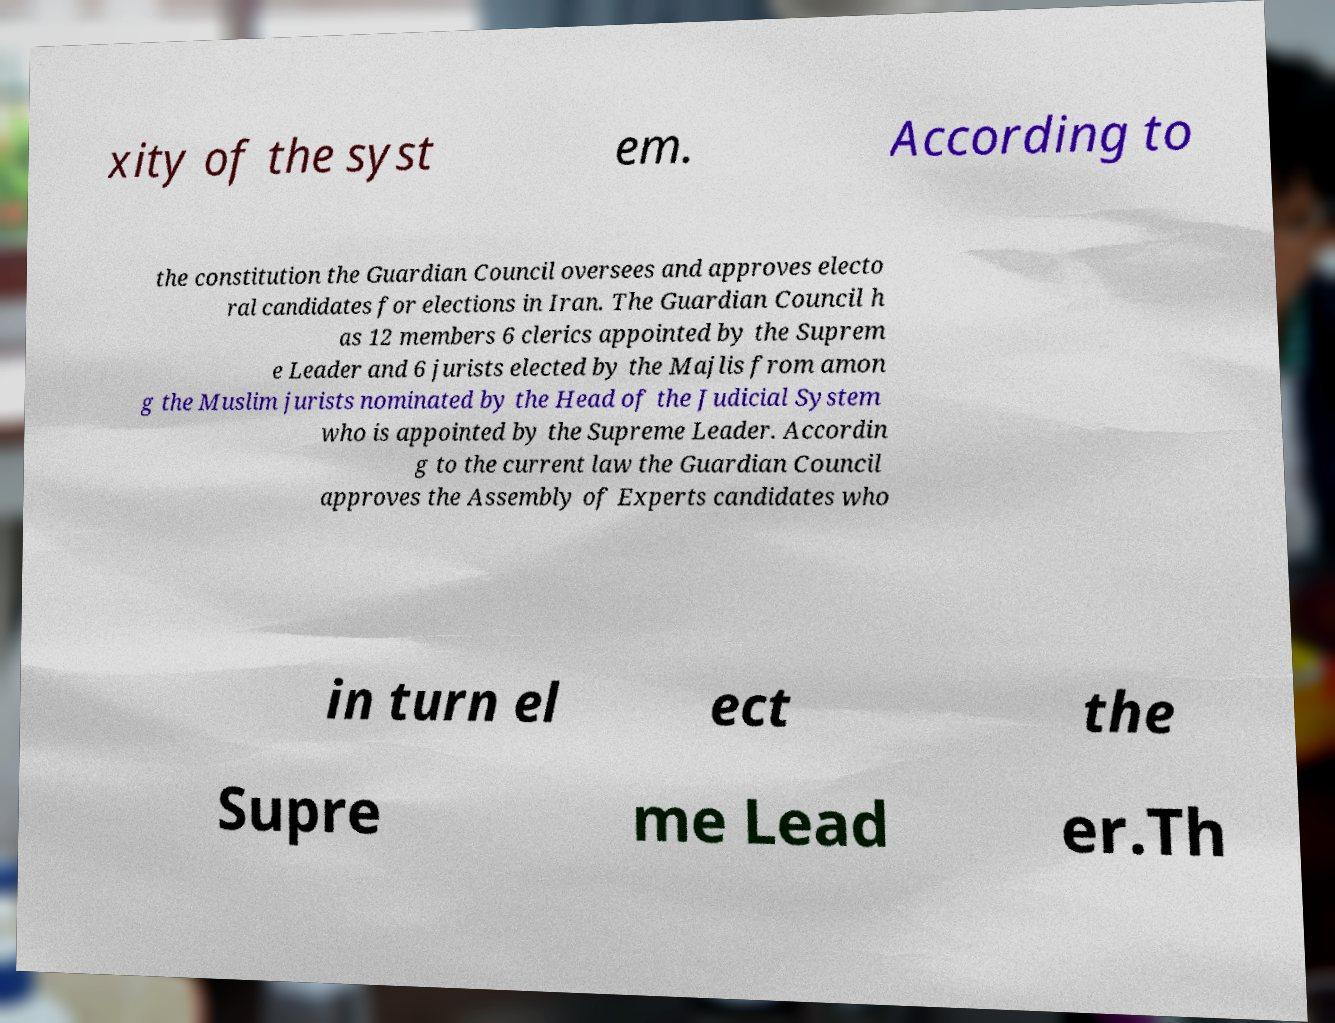Could you extract and type out the text from this image? xity of the syst em. According to the constitution the Guardian Council oversees and approves electo ral candidates for elections in Iran. The Guardian Council h as 12 members 6 clerics appointed by the Suprem e Leader and 6 jurists elected by the Majlis from amon g the Muslim jurists nominated by the Head of the Judicial System who is appointed by the Supreme Leader. Accordin g to the current law the Guardian Council approves the Assembly of Experts candidates who in turn el ect the Supre me Lead er.Th 